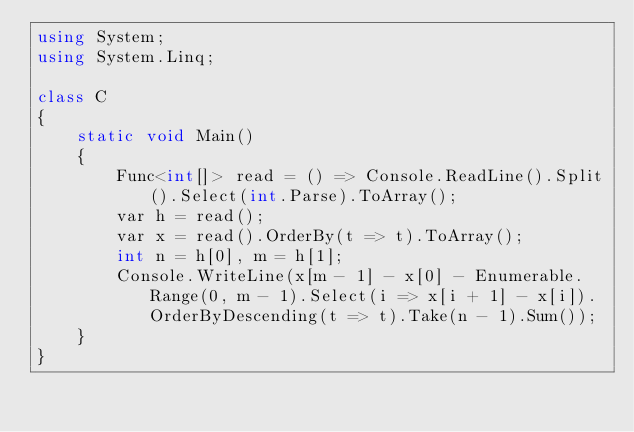<code> <loc_0><loc_0><loc_500><loc_500><_C#_>using System;
using System.Linq;

class C
{
	static void Main()
	{
		Func<int[]> read = () => Console.ReadLine().Split().Select(int.Parse).ToArray();
		var h = read();
		var x = read().OrderBy(t => t).ToArray();
		int n = h[0], m = h[1];
		Console.WriteLine(x[m - 1] - x[0] - Enumerable.Range(0, m - 1).Select(i => x[i + 1] - x[i]).OrderByDescending(t => t).Take(n - 1).Sum());
	}
}
</code> 